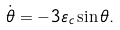<formula> <loc_0><loc_0><loc_500><loc_500>\dot { \theta } = - 3 \varepsilon _ { c } \sin \theta .</formula> 